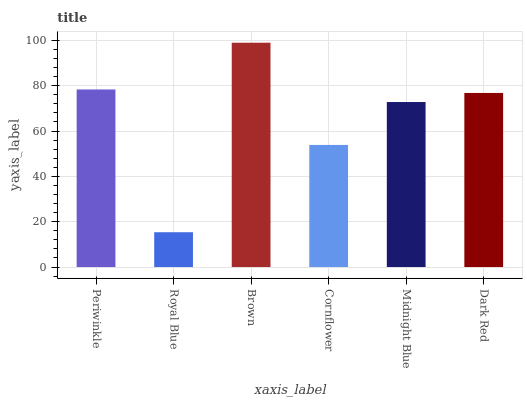Is Brown the minimum?
Answer yes or no. No. Is Royal Blue the maximum?
Answer yes or no. No. Is Brown greater than Royal Blue?
Answer yes or no. Yes. Is Royal Blue less than Brown?
Answer yes or no. Yes. Is Royal Blue greater than Brown?
Answer yes or no. No. Is Brown less than Royal Blue?
Answer yes or no. No. Is Dark Red the high median?
Answer yes or no. Yes. Is Midnight Blue the low median?
Answer yes or no. Yes. Is Midnight Blue the high median?
Answer yes or no. No. Is Dark Red the low median?
Answer yes or no. No. 